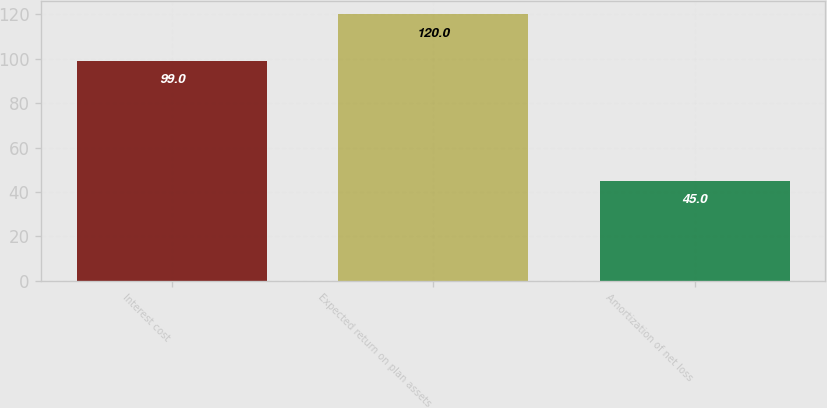<chart> <loc_0><loc_0><loc_500><loc_500><bar_chart><fcel>Interest cost<fcel>Expected return on plan assets<fcel>Amortization of net loss<nl><fcel>99<fcel>120<fcel>45<nl></chart> 